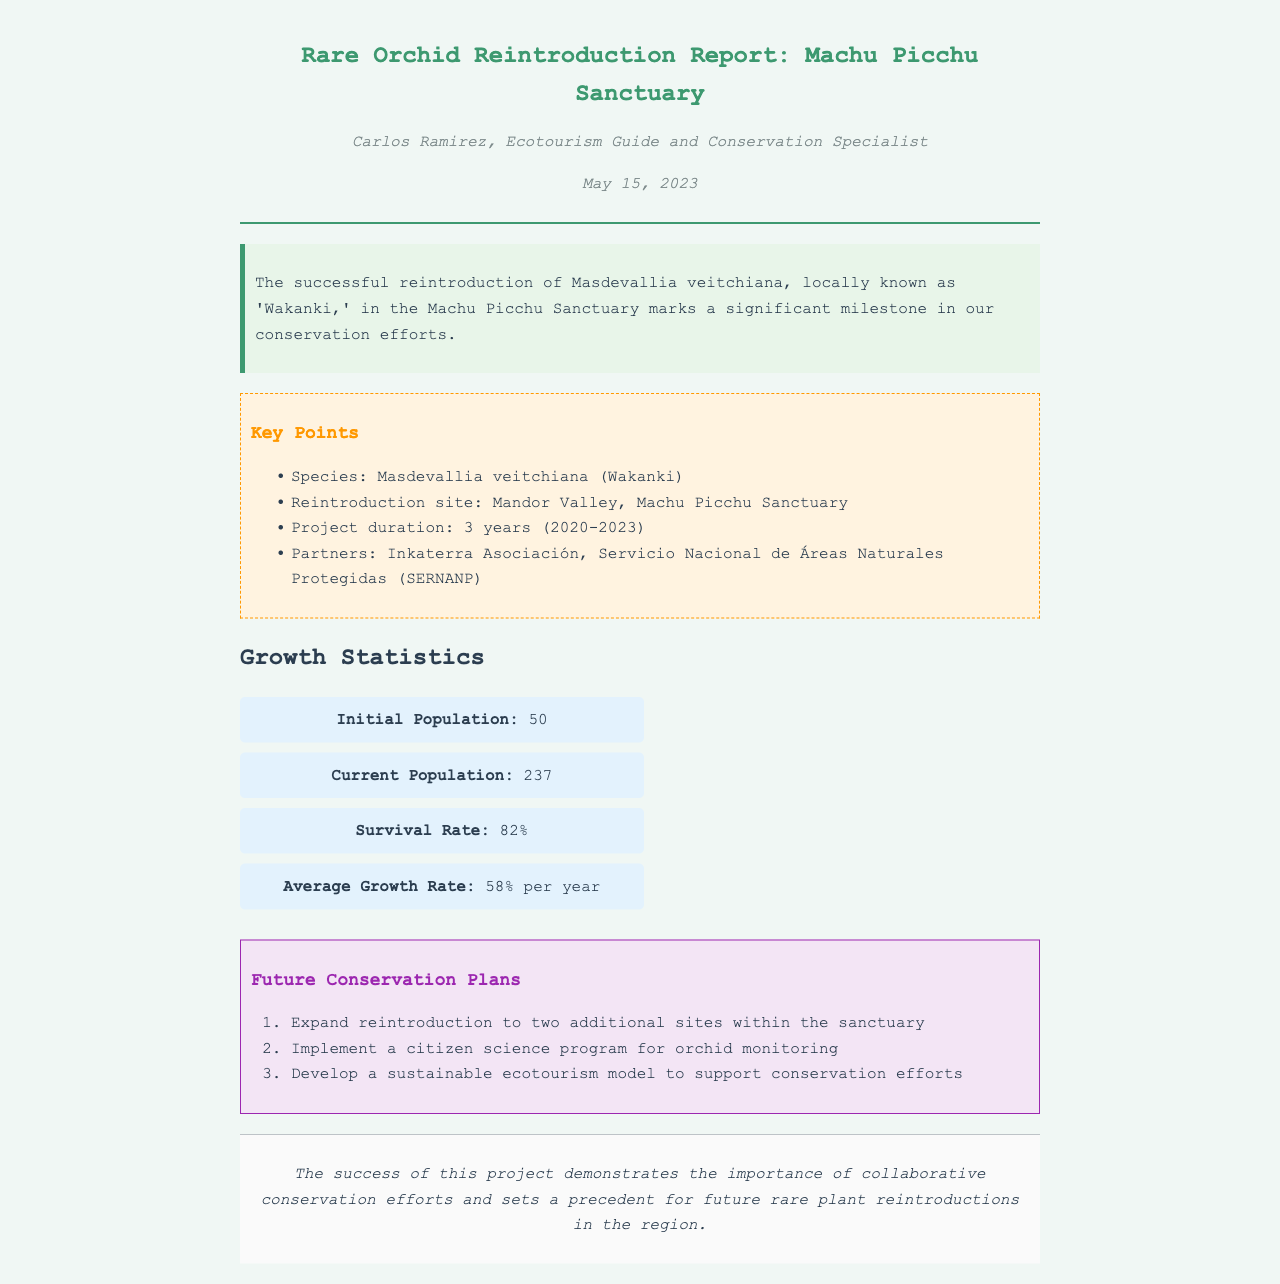what is the species introduced? The document states that the species reintroduced is Masdevallia veitchiana.
Answer: Masdevallia veitchiana where was the reintroduction site? The reintroduction site mentioned is Mandor Valley.
Answer: Mandor Valley what is the initial population of the orchid? The initial population of the orchid is provided as 50.
Answer: 50 what was the survival rate of the reintroduced orchids? The survival rate stated in the document is 82%.
Answer: 82% what is one of the future conservation plans? One of the future conservation plans includes expanding reintroduction to two additional sites.
Answer: Expand reintroduction to two additional sites how many partners were involved in the project? The document lists two partners involved in the project.
Answer: 2 what was the project duration? The project duration is specified as 3 years.
Answer: 3 years what is the average growth rate per year? The average growth rate per year mentioned is 58%.
Answer: 58% what does the conclusion emphasize about the project? The conclusion emphasizes the importance of collaborative conservation efforts.
Answer: Collaborative conservation efforts which organization is associated with this project? The organization associated with the project is Inkaterra Asociación.
Answer: Inkaterra Asociación 